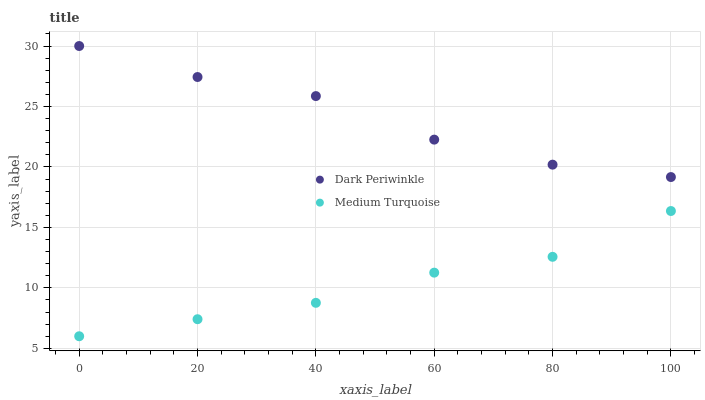Does Medium Turquoise have the minimum area under the curve?
Answer yes or no. Yes. Does Dark Periwinkle have the maximum area under the curve?
Answer yes or no. Yes. Does Medium Turquoise have the maximum area under the curve?
Answer yes or no. No. Is Medium Turquoise the smoothest?
Answer yes or no. Yes. Is Dark Periwinkle the roughest?
Answer yes or no. Yes. Is Medium Turquoise the roughest?
Answer yes or no. No. Does Medium Turquoise have the lowest value?
Answer yes or no. Yes. Does Dark Periwinkle have the highest value?
Answer yes or no. Yes. Does Medium Turquoise have the highest value?
Answer yes or no. No. Is Medium Turquoise less than Dark Periwinkle?
Answer yes or no. Yes. Is Dark Periwinkle greater than Medium Turquoise?
Answer yes or no. Yes. Does Medium Turquoise intersect Dark Periwinkle?
Answer yes or no. No. 